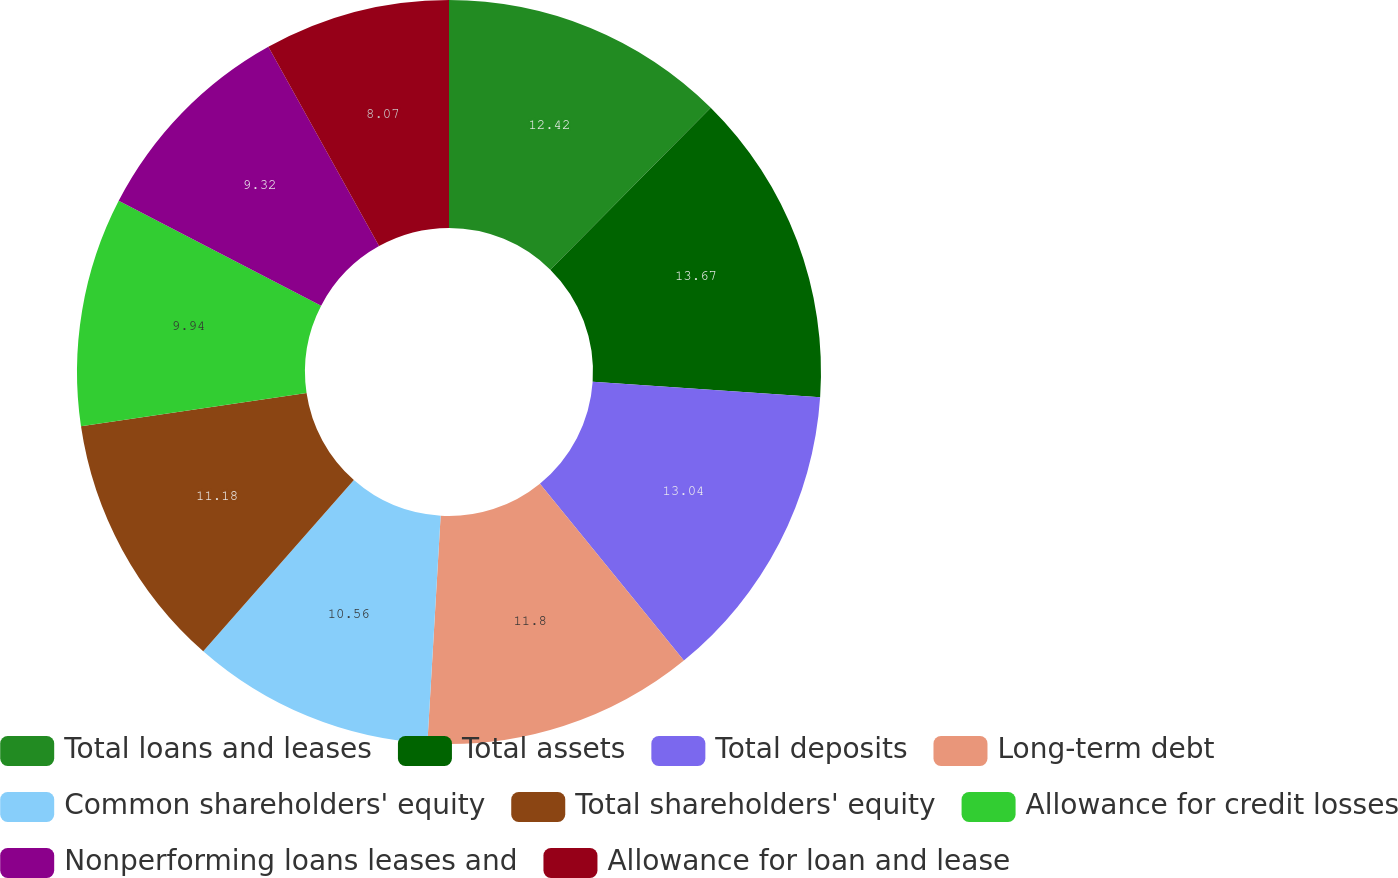Convert chart. <chart><loc_0><loc_0><loc_500><loc_500><pie_chart><fcel>Total loans and leases<fcel>Total assets<fcel>Total deposits<fcel>Long-term debt<fcel>Common shareholders' equity<fcel>Total shareholders' equity<fcel>Allowance for credit losses<fcel>Nonperforming loans leases and<fcel>Allowance for loan and lease<nl><fcel>12.42%<fcel>13.66%<fcel>13.04%<fcel>11.8%<fcel>10.56%<fcel>11.18%<fcel>9.94%<fcel>9.32%<fcel>8.07%<nl></chart> 